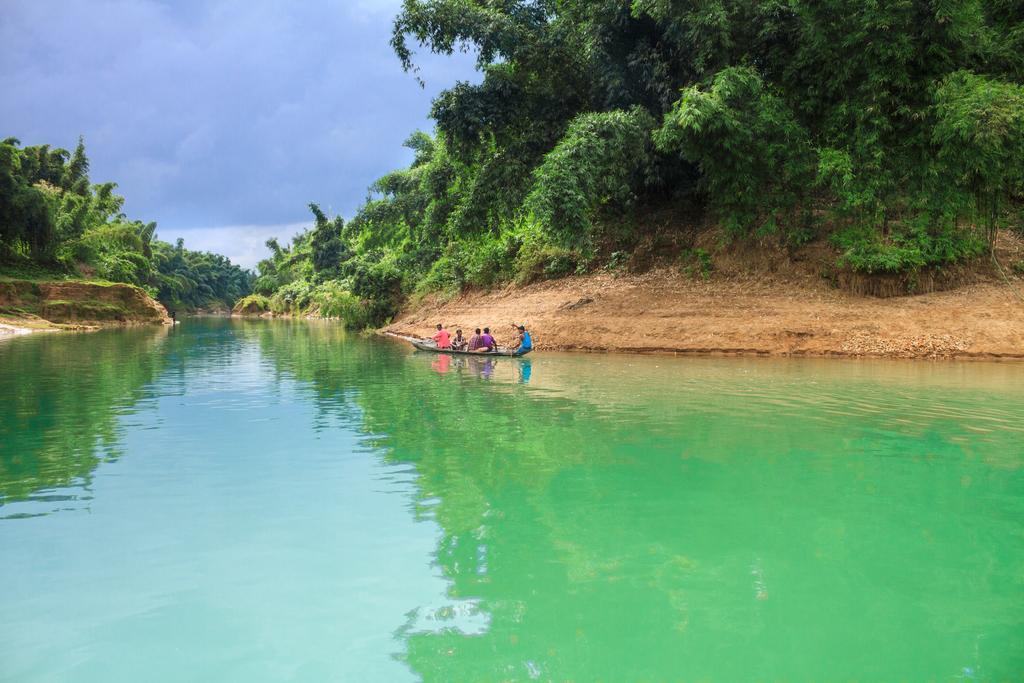Describe this image in one or two sentences. In this picture we can see a boat on water, on this boat we can see people and in the background we can see trees, sky. 